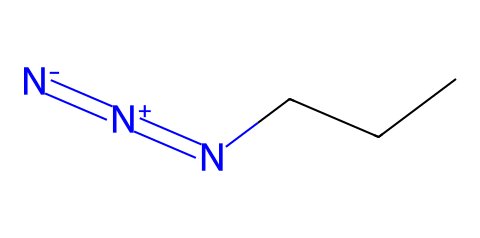What is the total number of atoms in 1-azidopropane? To find the total number of atoms, we need to count the atoms present in the structure given by the SMILES notation. The structure has 3 carbon atoms (C), 8 hydrogen atoms (H), and 3 nitrogen atoms (N). Adding these together gives 3 + 8 + 3 = 14.
Answer: 14 How many nitrogen atoms are in 1-azidopropane? The SMILES notation includes three nitrogen atoms denoted by the "N" characters. Therefore, by simply counting these symbols in the structure, we find there are 3 nitrogen atoms.
Answer: 3 What type of chemical is 1-azidopropane classified as? The structure features a nitrogen-nitrogen bond, typical of azides. The presence of the azide functional group (-N3) indicates that this compound belongs to the azide family.
Answer: azide What is the longest carbon chain in 1-azidopropane? The structure includes 3 carbon atoms linked in a straight chain (propane). In this case, the chain is simply comprised of the three carbon atoms connected sequentially without any branching.
Answer: three What kind of bond do the nitrogen atoms have in 1-azidopropane? Looking at the structure, the nitrogen atoms form a nitrogen-nitrogen double bond as indicated by the connection between two "N" atoms in the SMILES. This type of bond is characteristic of azide compounds.
Answer: double bond Does 1-azidopropane contain any functional groups? The presence of the azide functional group (-N3) clearly shows that 1-azidopropane contains a functional group specific to azides, which is essential in determining its reactivity in flavoring production.
Answer: azide group 